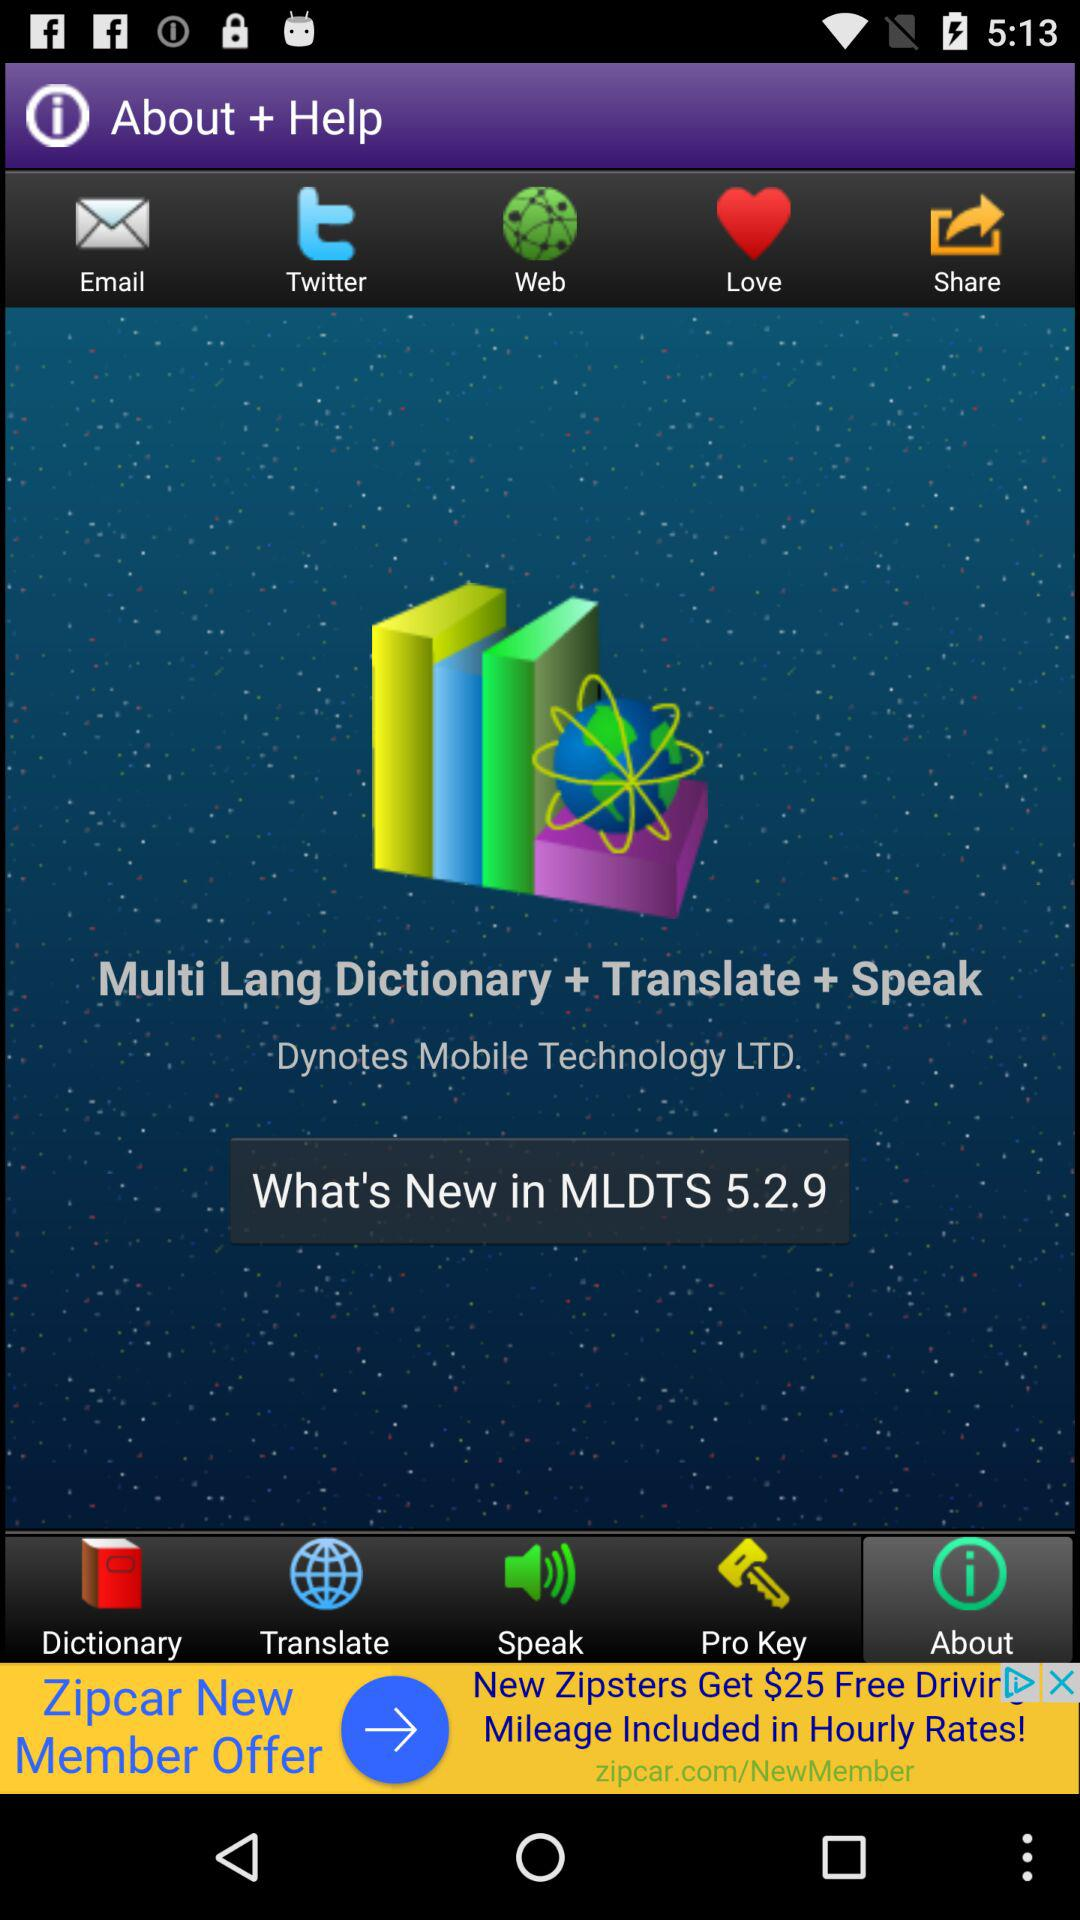What is the name of the company? The name of the company is "Dynotes Mobile Technology LTD.". 